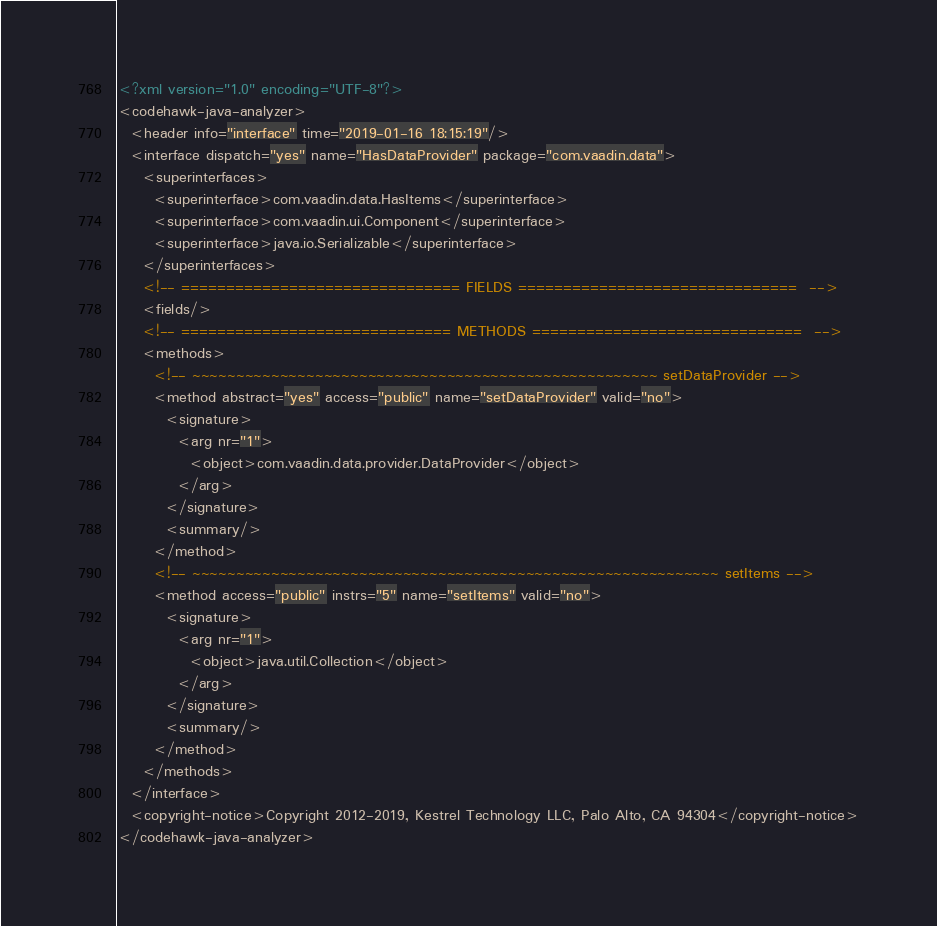Convert code to text. <code><loc_0><loc_0><loc_500><loc_500><_XML_><?xml version="1.0" encoding="UTF-8"?>
<codehawk-java-analyzer>
  <header info="interface" time="2019-01-16 18:15:19"/>
  <interface dispatch="yes" name="HasDataProvider" package="com.vaadin.data">
    <superinterfaces>
      <superinterface>com.vaadin.data.HasItems</superinterface>
      <superinterface>com.vaadin.ui.Component</superinterface>
      <superinterface>java.io.Serializable</superinterface>
    </superinterfaces>
    <!-- =============================== FIELDS ===============================  -->
    <fields/>
    <!-- ============================== METHODS ==============================  -->
    <methods>
      <!-- ~~~~~~~~~~~~~~~~~~~~~~~~~~~~~~~~~~~~~~~~~~~~~~~~~~~~~ setDataProvider -->
      <method abstract="yes" access="public" name="setDataProvider" valid="no">
        <signature>
          <arg nr="1">
            <object>com.vaadin.data.provider.DataProvider</object>
          </arg>
        </signature>
        <summary/>
      </method>
      <!-- ~~~~~~~~~~~~~~~~~~~~~~~~~~~~~~~~~~~~~~~~~~~~~~~~~~~~~~~~~~~~ setItems -->
      <method access="public" instrs="5" name="setItems" valid="no">
        <signature>
          <arg nr="1">
            <object>java.util.Collection</object>
          </arg>
        </signature>
        <summary/>
      </method>
    </methods>
  </interface>
  <copyright-notice>Copyright 2012-2019, Kestrel Technology LLC, Palo Alto, CA 94304</copyright-notice>
</codehawk-java-analyzer>
</code> 